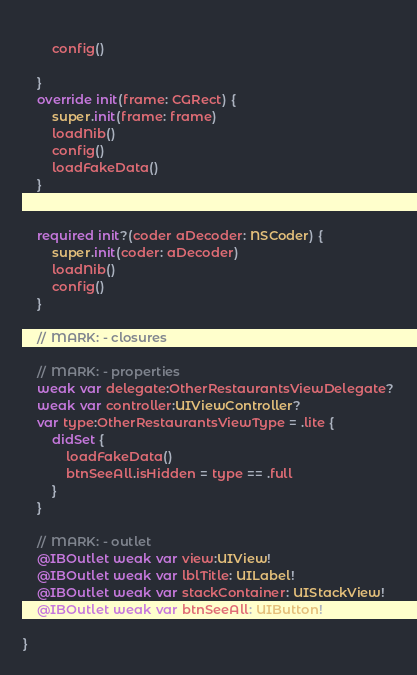Convert code to text. <code><loc_0><loc_0><loc_500><loc_500><_Swift_>        
        config()
        
    }
    override init(frame: CGRect) {
        super.init(frame: frame)
        loadNib()
        config()
        loadFakeData()
    }
    
    
    required init?(coder aDecoder: NSCoder) {
        super.init(coder: aDecoder)
        loadNib()
        config()
    }
    
    // MARK: - closures
    
    // MARK: - properties
    weak var delegate:OtherRestaurantsViewDelegate?
    weak var controller:UIViewController?
    var type:OtherRestaurantsViewType = .lite {
        didSet {
            loadFakeData()
            btnSeeAll.isHidden = type == .full
        }
    }
    
    // MARK: - outlet
    @IBOutlet weak var view:UIView!
    @IBOutlet weak var lblTitle: UILabel!
    @IBOutlet weak var stackContainer: UIStackView!
    @IBOutlet weak var btnSeeAll: UIButton!
    
}
</code> 